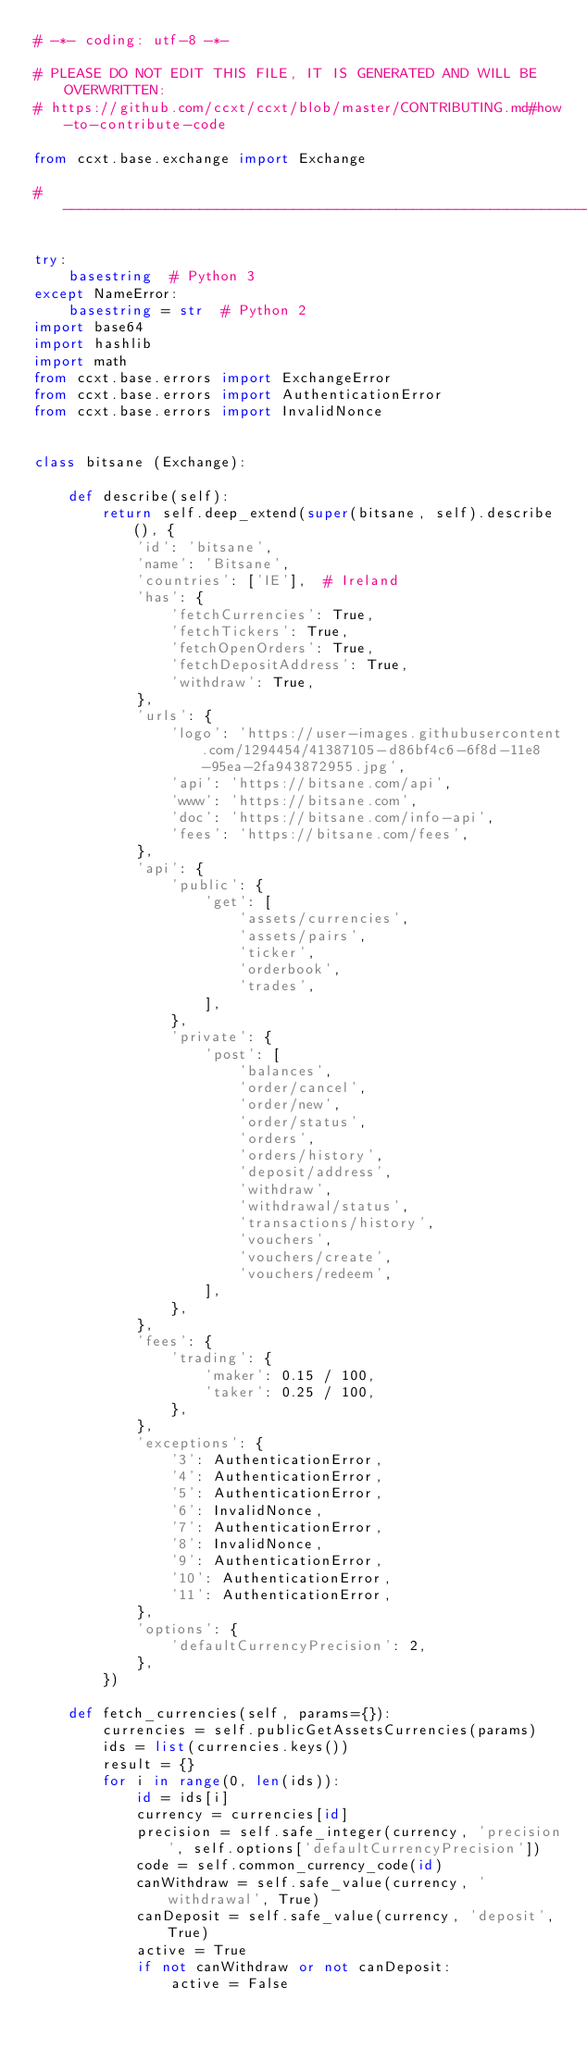<code> <loc_0><loc_0><loc_500><loc_500><_Python_># -*- coding: utf-8 -*-

# PLEASE DO NOT EDIT THIS FILE, IT IS GENERATED AND WILL BE OVERWRITTEN:
# https://github.com/ccxt/ccxt/blob/master/CONTRIBUTING.md#how-to-contribute-code

from ccxt.base.exchange import Exchange

# -----------------------------------------------------------------------------

try:
    basestring  # Python 3
except NameError:
    basestring = str  # Python 2
import base64
import hashlib
import math
from ccxt.base.errors import ExchangeError
from ccxt.base.errors import AuthenticationError
from ccxt.base.errors import InvalidNonce


class bitsane (Exchange):

    def describe(self):
        return self.deep_extend(super(bitsane, self).describe(), {
            'id': 'bitsane',
            'name': 'Bitsane',
            'countries': ['IE'],  # Ireland
            'has': {
                'fetchCurrencies': True,
                'fetchTickers': True,
                'fetchOpenOrders': True,
                'fetchDepositAddress': True,
                'withdraw': True,
            },
            'urls': {
                'logo': 'https://user-images.githubusercontent.com/1294454/41387105-d86bf4c6-6f8d-11e8-95ea-2fa943872955.jpg',
                'api': 'https://bitsane.com/api',
                'www': 'https://bitsane.com',
                'doc': 'https://bitsane.com/info-api',
                'fees': 'https://bitsane.com/fees',
            },
            'api': {
                'public': {
                    'get': [
                        'assets/currencies',
                        'assets/pairs',
                        'ticker',
                        'orderbook',
                        'trades',
                    ],
                },
                'private': {
                    'post': [
                        'balances',
                        'order/cancel',
                        'order/new',
                        'order/status',
                        'orders',
                        'orders/history',
                        'deposit/address',
                        'withdraw',
                        'withdrawal/status',
                        'transactions/history',
                        'vouchers',
                        'vouchers/create',
                        'vouchers/redeem',
                    ],
                },
            },
            'fees': {
                'trading': {
                    'maker': 0.15 / 100,
                    'taker': 0.25 / 100,
                },
            },
            'exceptions': {
                '3': AuthenticationError,
                '4': AuthenticationError,
                '5': AuthenticationError,
                '6': InvalidNonce,
                '7': AuthenticationError,
                '8': InvalidNonce,
                '9': AuthenticationError,
                '10': AuthenticationError,
                '11': AuthenticationError,
            },
            'options': {
                'defaultCurrencyPrecision': 2,
            },
        })

    def fetch_currencies(self, params={}):
        currencies = self.publicGetAssetsCurrencies(params)
        ids = list(currencies.keys())
        result = {}
        for i in range(0, len(ids)):
            id = ids[i]
            currency = currencies[id]
            precision = self.safe_integer(currency, 'precision', self.options['defaultCurrencyPrecision'])
            code = self.common_currency_code(id)
            canWithdraw = self.safe_value(currency, 'withdrawal', True)
            canDeposit = self.safe_value(currency, 'deposit', True)
            active = True
            if not canWithdraw or not canDeposit:
                active = False</code> 